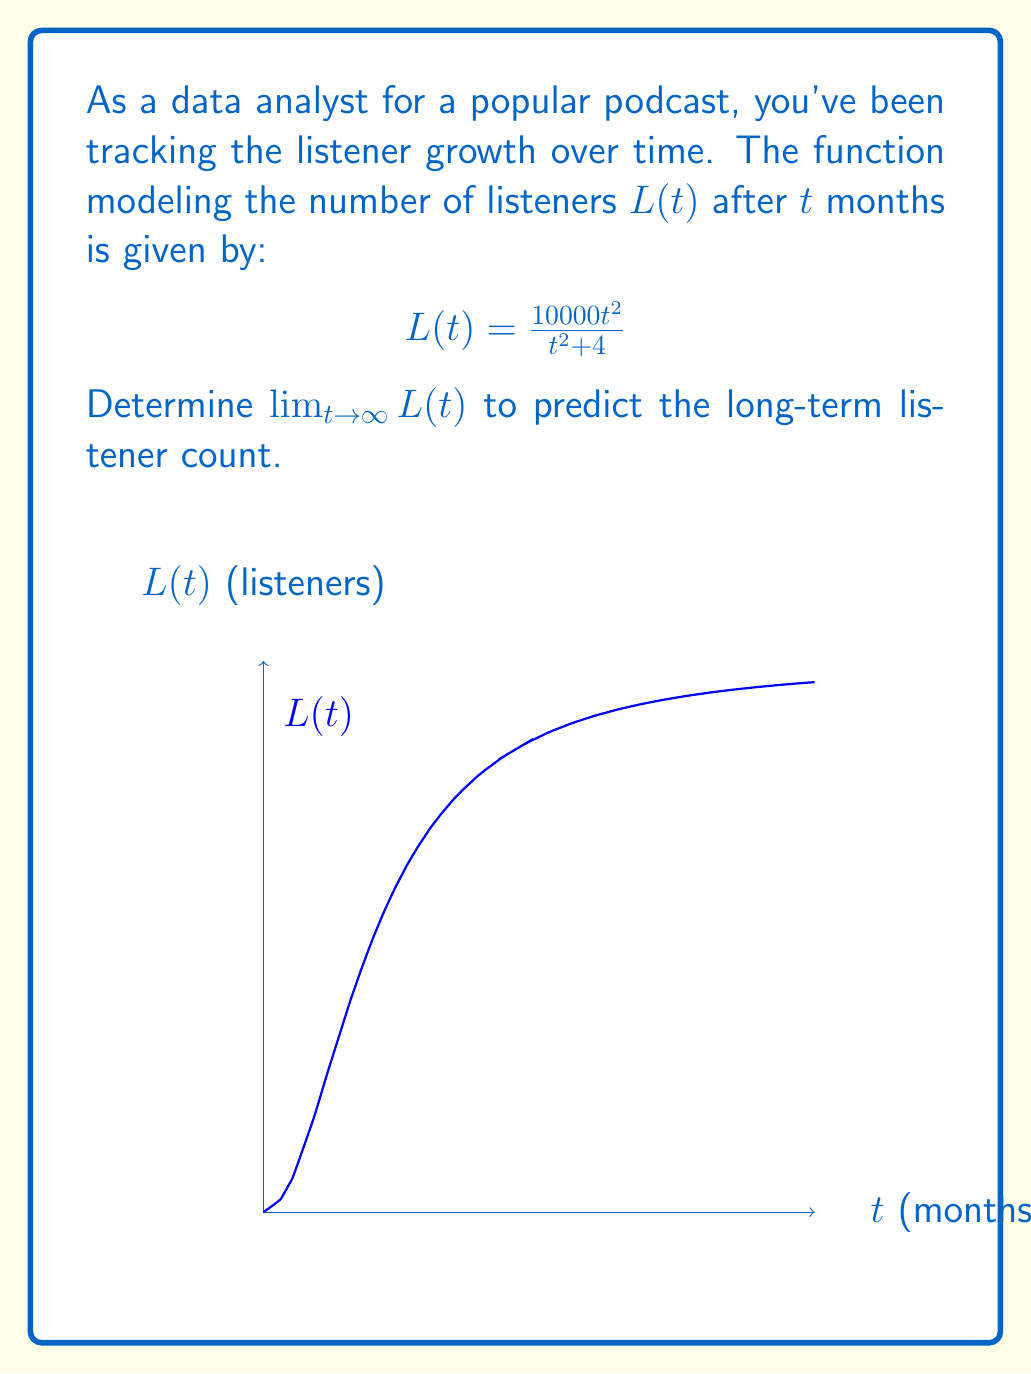Provide a solution to this math problem. To find $\lim_{t \to \infty} L(t)$, we'll follow these steps:

1) First, let's examine the function:
   $$L(t) = \frac{10000t^2}{t^2 + 4}$$

2) As $t$ approaches infinity, both the numerator and denominator will grow very large. We can use the method of dividing the highest degree terms:

3) Divide both numerator and denominator by $t^2$:
   $$\lim_{t \to \infty} L(t) = \lim_{t \to \infty} \frac{10000t^2}{t^2 + 4} = \lim_{t \to \infty} \frac{10000}{1 + \frac{4}{t^2}}$$

4) As $t$ approaches infinity, $\frac{4}{t^2}$ approaches 0:
   $$\lim_{t \to \infty} \frac{10000}{1 + \frac{4}{t^2}} = \frac{10000}{1 + 0} = 10000$$

5) Therefore, the limit of the function as $t$ approaches infinity is 10000.

This means that in the long term, the podcast is predicted to reach a maximum of 10,000 listeners.
Answer: $10000$ 